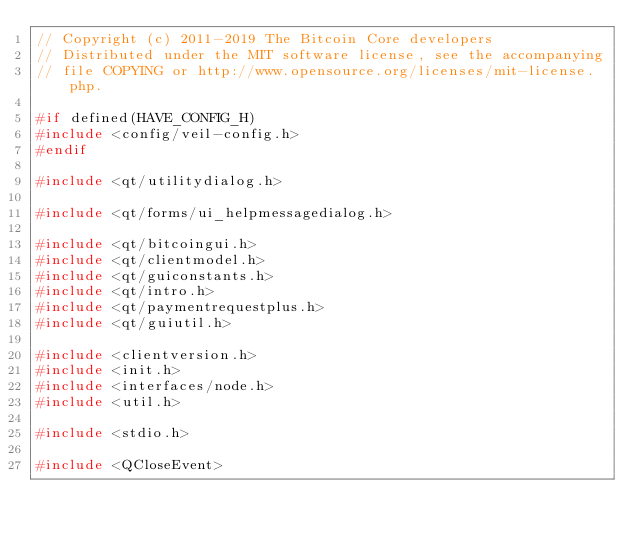Convert code to text. <code><loc_0><loc_0><loc_500><loc_500><_C++_>// Copyright (c) 2011-2019 The Bitcoin Core developers
// Distributed under the MIT software license, see the accompanying
// file COPYING or http://www.opensource.org/licenses/mit-license.php.

#if defined(HAVE_CONFIG_H)
#include <config/veil-config.h>
#endif

#include <qt/utilitydialog.h>

#include <qt/forms/ui_helpmessagedialog.h>

#include <qt/bitcoingui.h>
#include <qt/clientmodel.h>
#include <qt/guiconstants.h>
#include <qt/intro.h>
#include <qt/paymentrequestplus.h>
#include <qt/guiutil.h>

#include <clientversion.h>
#include <init.h>
#include <interfaces/node.h>
#include <util.h>

#include <stdio.h>

#include <QCloseEvent></code> 